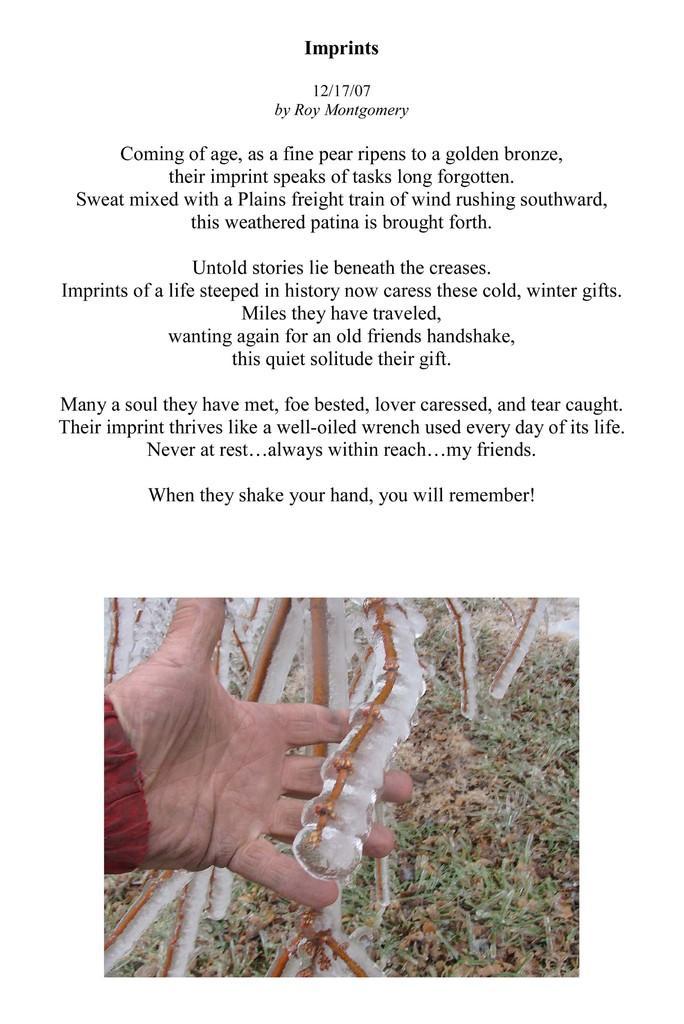Can you describe this image briefly? In the image there is a person holding stick and below its grassland with text above it. 